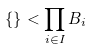Convert formula to latex. <formula><loc_0><loc_0><loc_500><loc_500>\{ \} < \prod _ { i \in I } B _ { i }</formula> 